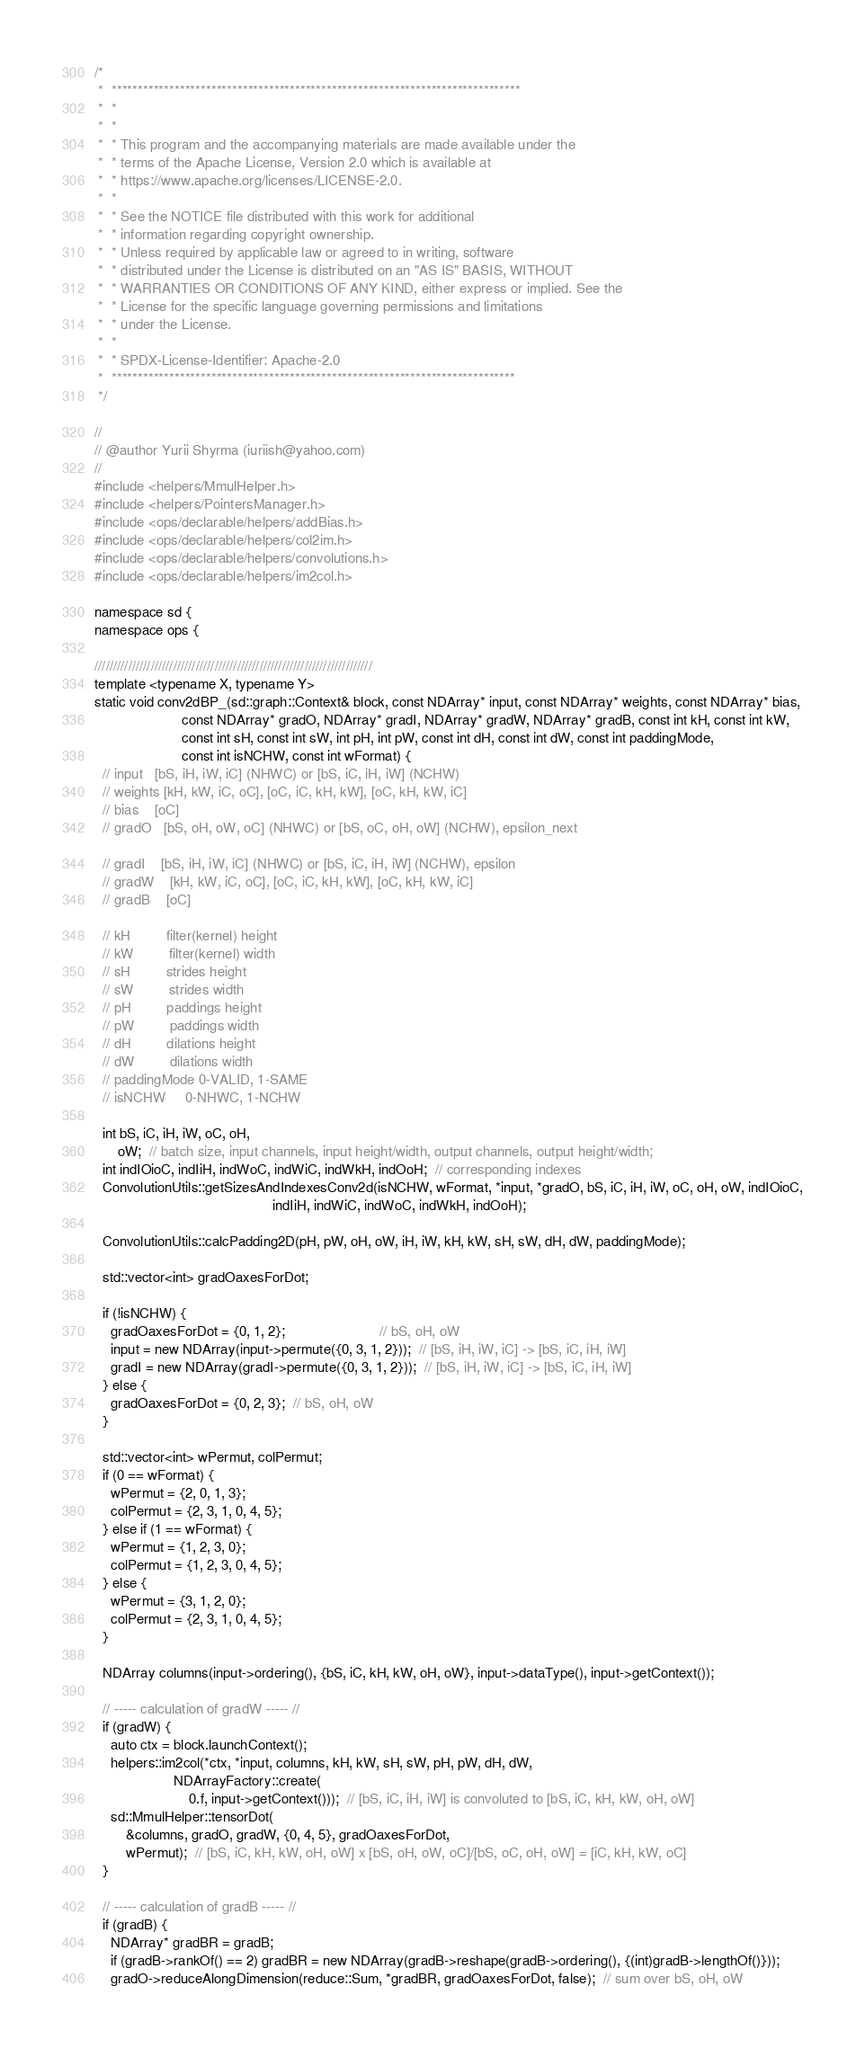Convert code to text. <code><loc_0><loc_0><loc_500><loc_500><_Cuda_>/*
 *  ******************************************************************************
 *  *
 *  *
 *  * This program and the accompanying materials are made available under the
 *  * terms of the Apache License, Version 2.0 which is available at
 *  * https://www.apache.org/licenses/LICENSE-2.0.
 *  *
 *  * See the NOTICE file distributed with this work for additional
 *  * information regarding copyright ownership.
 *  * Unless required by applicable law or agreed to in writing, software
 *  * distributed under the License is distributed on an "AS IS" BASIS, WITHOUT
 *  * WARRANTIES OR CONDITIONS OF ANY KIND, either express or implied. See the
 *  * License for the specific language governing permissions and limitations
 *  * under the License.
 *  *
 *  * SPDX-License-Identifier: Apache-2.0
 *  *****************************************************************************
 */

//
// @author Yurii Shyrma (iuriish@yahoo.com)
//
#include <helpers/MmulHelper.h>
#include <helpers/PointersManager.h>
#include <ops/declarable/helpers/addBias.h>
#include <ops/declarable/helpers/col2im.h>
#include <ops/declarable/helpers/convolutions.h>
#include <ops/declarable/helpers/im2col.h>

namespace sd {
namespace ops {

//////////////////////////////////////////////////////////////////////////
template <typename X, typename Y>
static void conv2dBP_(sd::graph::Context& block, const NDArray* input, const NDArray* weights, const NDArray* bias,
                      const NDArray* gradO, NDArray* gradI, NDArray* gradW, NDArray* gradB, const int kH, const int kW,
                      const int sH, const int sW, int pH, int pW, const int dH, const int dW, const int paddingMode,
                      const int isNCHW, const int wFormat) {
  // input   [bS, iH, iW, iC] (NHWC) or [bS, iC, iH, iW] (NCHW)
  // weights [kH, kW, iC, oC], [oC, iC, kH, kW], [oC, kH, kW, iC]
  // bias    [oC]
  // gradO   [bS, oH, oW, oC] (NHWC) or [bS, oC, oH, oW] (NCHW), epsilon_next

  // gradI    [bS, iH, iW, iC] (NHWC) or [bS, iC, iH, iW] (NCHW), epsilon
  // gradW    [kH, kW, iC, oC], [oC, iC, kH, kW], [oC, kH, kW, iC]
  // gradB    [oC]

  // kH         filter(kernel) height
  // kW         filter(kernel) width
  // sH         strides height
  // sW         strides width
  // pH         paddings height
  // pW         paddings width
  // dH         dilations height
  // dW         dilations width
  // paddingMode 0-VALID, 1-SAME
  // isNCHW     0-NHWC, 1-NCHW

  int bS, iC, iH, iW, oC, oH,
      oW;  // batch size, input channels, input height/width, output channels, output height/width;
  int indIOioC, indIiH, indWoC, indWiC, indWkH, indOoH;  // corresponding indexes
  ConvolutionUtils::getSizesAndIndexesConv2d(isNCHW, wFormat, *input, *gradO, bS, iC, iH, iW, oC, oH, oW, indIOioC,
                                             indIiH, indWiC, indWoC, indWkH, indOoH);

  ConvolutionUtils::calcPadding2D(pH, pW, oH, oW, iH, iW, kH, kW, sH, sW, dH, dW, paddingMode);

  std::vector<int> gradOaxesForDot;

  if (!isNCHW) {
    gradOaxesForDot = {0, 1, 2};                        // bS, oH, oW
    input = new NDArray(input->permute({0, 3, 1, 2}));  // [bS, iH, iW, iC] -> [bS, iC, iH, iW]
    gradI = new NDArray(gradI->permute({0, 3, 1, 2}));  // [bS, iH, iW, iC] -> [bS, iC, iH, iW]
  } else {
    gradOaxesForDot = {0, 2, 3};  // bS, oH, oW
  }

  std::vector<int> wPermut, colPermut;
  if (0 == wFormat) {
    wPermut = {2, 0, 1, 3};
    colPermut = {2, 3, 1, 0, 4, 5};
  } else if (1 == wFormat) {
    wPermut = {1, 2, 3, 0};
    colPermut = {1, 2, 3, 0, 4, 5};
  } else {
    wPermut = {3, 1, 2, 0};
    colPermut = {2, 3, 1, 0, 4, 5};
  }

  NDArray columns(input->ordering(), {bS, iC, kH, kW, oH, oW}, input->dataType(), input->getContext());

  // ----- calculation of gradW ----- //
  if (gradW) {
    auto ctx = block.launchContext();
    helpers::im2col(*ctx, *input, columns, kH, kW, sH, sW, pH, pW, dH, dW,
                    NDArrayFactory::create(
                        0.f, input->getContext()));  // [bS, iC, iH, iW] is convoluted to [bS, iC, kH, kW, oH, oW]
    sd::MmulHelper::tensorDot(
        &columns, gradO, gradW, {0, 4, 5}, gradOaxesForDot,
        wPermut);  // [bS, iC, kH, kW, oH, oW] x [bS, oH, oW, oC]/[bS, oC, oH, oW] = [iC, kH, kW, oC]
  }

  // ----- calculation of gradB ----- //
  if (gradB) {
    NDArray* gradBR = gradB;
    if (gradB->rankOf() == 2) gradBR = new NDArray(gradB->reshape(gradB->ordering(), {(int)gradB->lengthOf()}));
    gradO->reduceAlongDimension(reduce::Sum, *gradBR, gradOaxesForDot, false);  // sum over bS, oH, oW</code> 